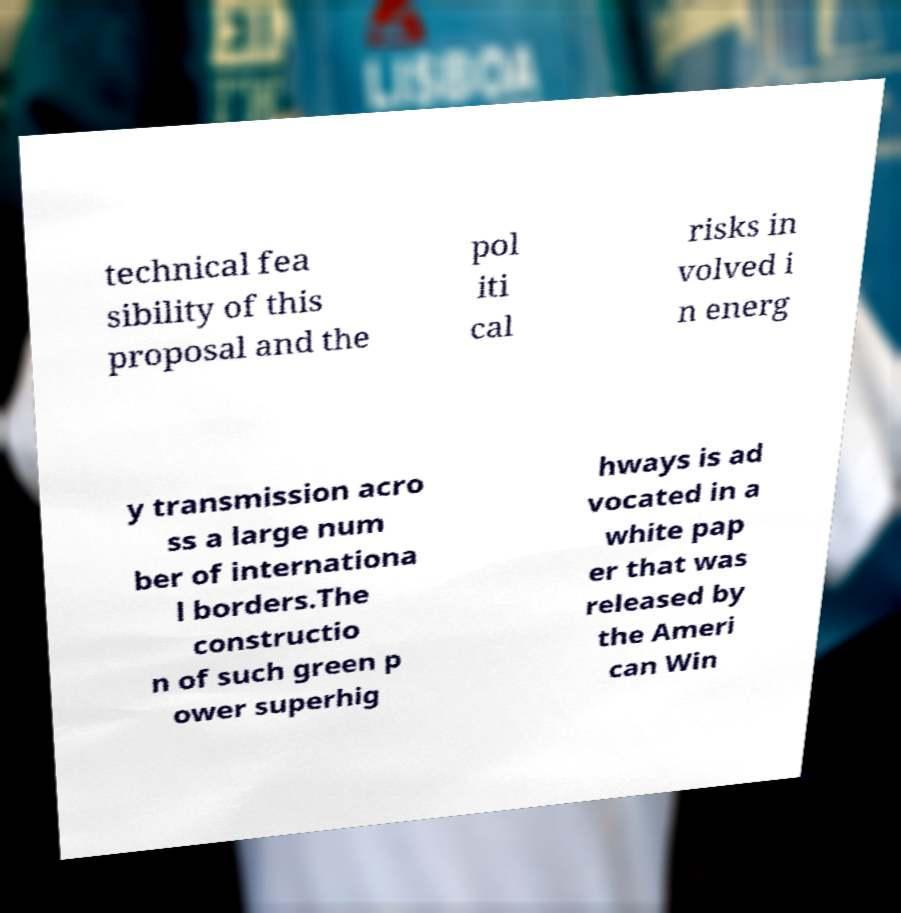Could you extract and type out the text from this image? technical fea sibility of this proposal and the pol iti cal risks in volved i n energ y transmission acro ss a large num ber of internationa l borders.The constructio n of such green p ower superhig hways is ad vocated in a white pap er that was released by the Ameri can Win 